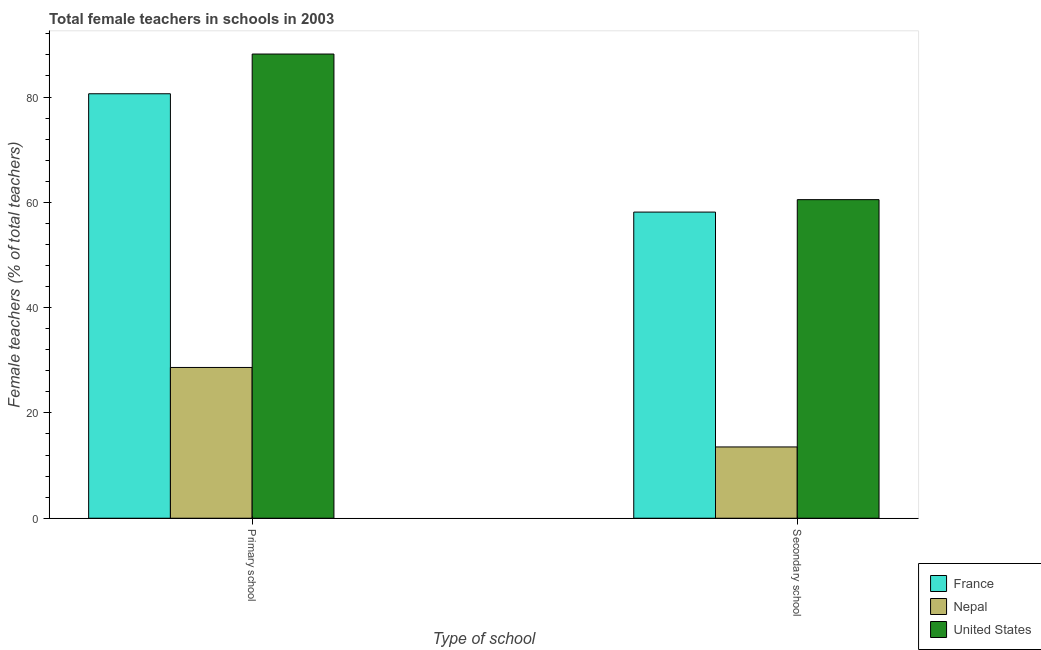How many different coloured bars are there?
Provide a short and direct response. 3. How many groups of bars are there?
Give a very brief answer. 2. Are the number of bars per tick equal to the number of legend labels?
Give a very brief answer. Yes. Are the number of bars on each tick of the X-axis equal?
Your answer should be compact. Yes. How many bars are there on the 2nd tick from the left?
Give a very brief answer. 3. How many bars are there on the 1st tick from the right?
Make the answer very short. 3. What is the label of the 2nd group of bars from the left?
Ensure brevity in your answer.  Secondary school. What is the percentage of female teachers in secondary schools in France?
Give a very brief answer. 58.15. Across all countries, what is the maximum percentage of female teachers in primary schools?
Offer a very short reply. 88.17. Across all countries, what is the minimum percentage of female teachers in primary schools?
Ensure brevity in your answer.  28.64. In which country was the percentage of female teachers in primary schools maximum?
Your response must be concise. United States. In which country was the percentage of female teachers in primary schools minimum?
Keep it short and to the point. Nepal. What is the total percentage of female teachers in primary schools in the graph?
Offer a terse response. 197.42. What is the difference between the percentage of female teachers in secondary schools in France and that in Nepal?
Ensure brevity in your answer.  44.61. What is the difference between the percentage of female teachers in primary schools in United States and the percentage of female teachers in secondary schools in Nepal?
Your response must be concise. 74.63. What is the average percentage of female teachers in secondary schools per country?
Ensure brevity in your answer.  44.07. What is the difference between the percentage of female teachers in secondary schools and percentage of female teachers in primary schools in Nepal?
Keep it short and to the point. -15.1. What is the ratio of the percentage of female teachers in primary schools in United States to that in France?
Your answer should be very brief. 1.09. What does the 2nd bar from the left in Secondary school represents?
Give a very brief answer. Nepal. What does the 2nd bar from the right in Primary school represents?
Your answer should be compact. Nepal. How many bars are there?
Make the answer very short. 6. Does the graph contain grids?
Offer a terse response. No. How many legend labels are there?
Keep it short and to the point. 3. How are the legend labels stacked?
Offer a very short reply. Vertical. What is the title of the graph?
Your answer should be compact. Total female teachers in schools in 2003. What is the label or title of the X-axis?
Your answer should be compact. Type of school. What is the label or title of the Y-axis?
Keep it short and to the point. Female teachers (% of total teachers). What is the Female teachers (% of total teachers) in France in Primary school?
Offer a terse response. 80.62. What is the Female teachers (% of total teachers) of Nepal in Primary school?
Make the answer very short. 28.64. What is the Female teachers (% of total teachers) of United States in Primary school?
Your answer should be compact. 88.17. What is the Female teachers (% of total teachers) in France in Secondary school?
Your answer should be very brief. 58.15. What is the Female teachers (% of total teachers) in Nepal in Secondary school?
Provide a short and direct response. 13.54. What is the Female teachers (% of total teachers) of United States in Secondary school?
Make the answer very short. 60.51. Across all Type of school, what is the maximum Female teachers (% of total teachers) of France?
Your answer should be very brief. 80.62. Across all Type of school, what is the maximum Female teachers (% of total teachers) of Nepal?
Provide a succinct answer. 28.64. Across all Type of school, what is the maximum Female teachers (% of total teachers) of United States?
Your answer should be very brief. 88.17. Across all Type of school, what is the minimum Female teachers (% of total teachers) in France?
Your answer should be compact. 58.15. Across all Type of school, what is the minimum Female teachers (% of total teachers) of Nepal?
Ensure brevity in your answer.  13.54. Across all Type of school, what is the minimum Female teachers (% of total teachers) in United States?
Your answer should be compact. 60.51. What is the total Female teachers (% of total teachers) of France in the graph?
Your answer should be compact. 138.77. What is the total Female teachers (% of total teachers) of Nepal in the graph?
Your response must be concise. 42.18. What is the total Female teachers (% of total teachers) of United States in the graph?
Your answer should be very brief. 148.68. What is the difference between the Female teachers (% of total teachers) in France in Primary school and that in Secondary school?
Your answer should be compact. 22.47. What is the difference between the Female teachers (% of total teachers) of Nepal in Primary school and that in Secondary school?
Keep it short and to the point. 15.1. What is the difference between the Female teachers (% of total teachers) in United States in Primary school and that in Secondary school?
Offer a terse response. 27.66. What is the difference between the Female teachers (% of total teachers) of France in Primary school and the Female teachers (% of total teachers) of Nepal in Secondary school?
Offer a very short reply. 67.08. What is the difference between the Female teachers (% of total teachers) in France in Primary school and the Female teachers (% of total teachers) in United States in Secondary school?
Ensure brevity in your answer.  20.11. What is the difference between the Female teachers (% of total teachers) in Nepal in Primary school and the Female teachers (% of total teachers) in United States in Secondary school?
Offer a very short reply. -31.87. What is the average Female teachers (% of total teachers) of France per Type of school?
Your answer should be very brief. 69.38. What is the average Female teachers (% of total teachers) in Nepal per Type of school?
Make the answer very short. 21.09. What is the average Female teachers (% of total teachers) in United States per Type of school?
Your answer should be compact. 74.34. What is the difference between the Female teachers (% of total teachers) of France and Female teachers (% of total teachers) of Nepal in Primary school?
Your answer should be compact. 51.98. What is the difference between the Female teachers (% of total teachers) in France and Female teachers (% of total teachers) in United States in Primary school?
Ensure brevity in your answer.  -7.55. What is the difference between the Female teachers (% of total teachers) of Nepal and Female teachers (% of total teachers) of United States in Primary school?
Give a very brief answer. -59.53. What is the difference between the Female teachers (% of total teachers) in France and Female teachers (% of total teachers) in Nepal in Secondary school?
Offer a very short reply. 44.61. What is the difference between the Female teachers (% of total teachers) in France and Female teachers (% of total teachers) in United States in Secondary school?
Your response must be concise. -2.36. What is the difference between the Female teachers (% of total teachers) in Nepal and Female teachers (% of total teachers) in United States in Secondary school?
Make the answer very short. -46.97. What is the ratio of the Female teachers (% of total teachers) of France in Primary school to that in Secondary school?
Offer a very short reply. 1.39. What is the ratio of the Female teachers (% of total teachers) of Nepal in Primary school to that in Secondary school?
Offer a terse response. 2.12. What is the ratio of the Female teachers (% of total teachers) in United States in Primary school to that in Secondary school?
Ensure brevity in your answer.  1.46. What is the difference between the highest and the second highest Female teachers (% of total teachers) in France?
Your response must be concise. 22.47. What is the difference between the highest and the second highest Female teachers (% of total teachers) in Nepal?
Ensure brevity in your answer.  15.1. What is the difference between the highest and the second highest Female teachers (% of total teachers) of United States?
Give a very brief answer. 27.66. What is the difference between the highest and the lowest Female teachers (% of total teachers) in France?
Offer a very short reply. 22.47. What is the difference between the highest and the lowest Female teachers (% of total teachers) of Nepal?
Provide a succinct answer. 15.1. What is the difference between the highest and the lowest Female teachers (% of total teachers) of United States?
Offer a terse response. 27.66. 